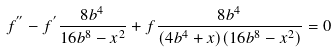<formula> <loc_0><loc_0><loc_500><loc_500>f ^ { ^ { \prime \prime } } - f ^ { ^ { \prime } } \frac { 8 b ^ { 4 } } { 1 6 b ^ { 8 } - x ^ { 2 } } + f \frac { 8 b ^ { 4 } } { ( 4 b ^ { 4 } + x ) ( 1 6 b ^ { 8 } - x ^ { 2 } ) } = 0</formula> 